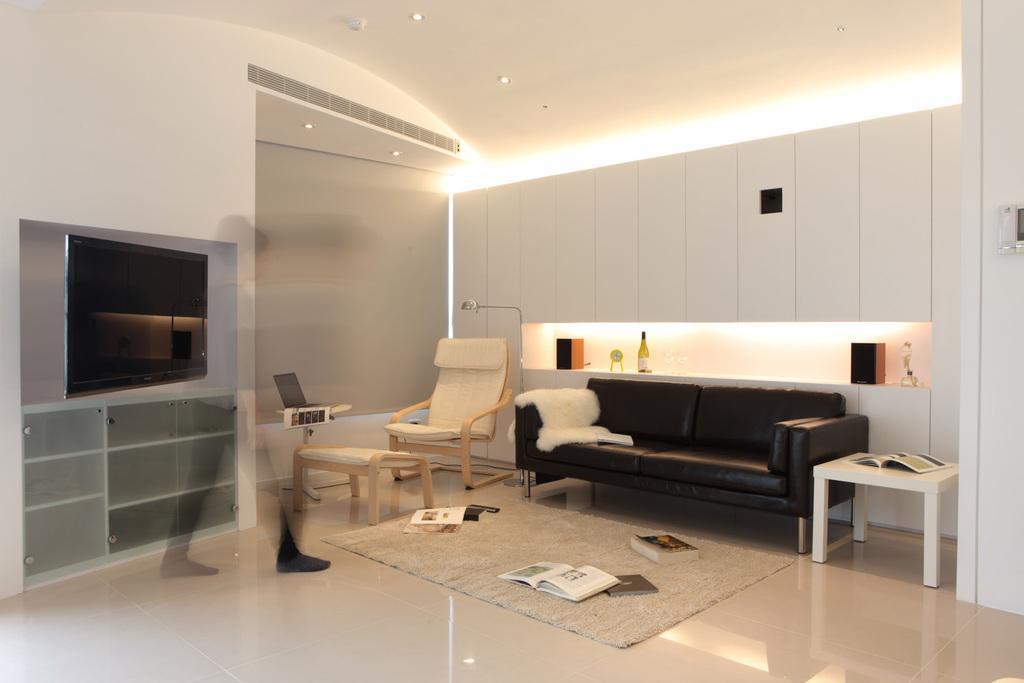Please provide a concise description of this image. In the image we can see there is black colour sofa and white colour chair and table and on the wall there is tv and there is an illusion of a person and on the floor there are books which are scattered and there is a floor mat. 